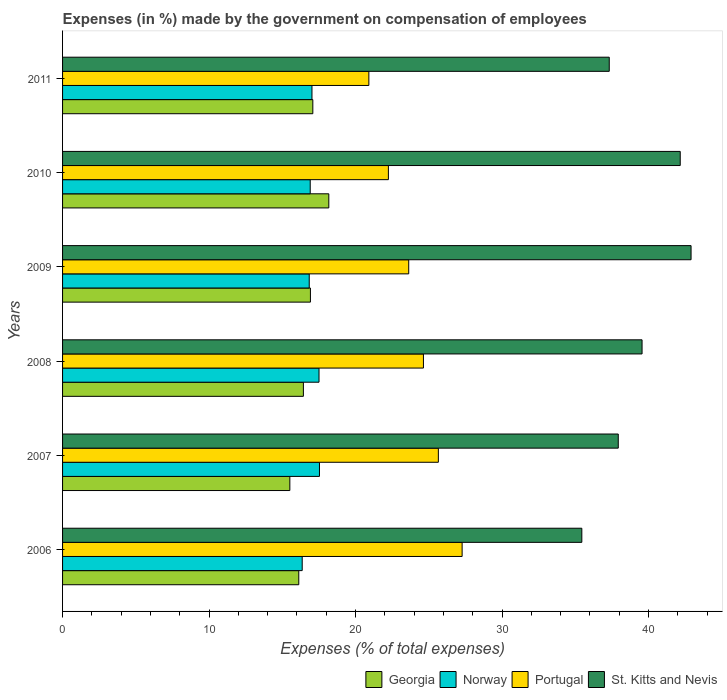How many different coloured bars are there?
Offer a very short reply. 4. Are the number of bars per tick equal to the number of legend labels?
Provide a short and direct response. Yes. Are the number of bars on each tick of the Y-axis equal?
Your answer should be compact. Yes. How many bars are there on the 5th tick from the bottom?
Ensure brevity in your answer.  4. In how many cases, is the number of bars for a given year not equal to the number of legend labels?
Provide a short and direct response. 0. What is the percentage of expenses made by the government on compensation of employees in Norway in 2008?
Your answer should be compact. 17.51. Across all years, what is the maximum percentage of expenses made by the government on compensation of employees in St. Kitts and Nevis?
Your response must be concise. 42.9. Across all years, what is the minimum percentage of expenses made by the government on compensation of employees in Norway?
Ensure brevity in your answer.  16.36. What is the total percentage of expenses made by the government on compensation of employees in Norway in the graph?
Make the answer very short. 102.17. What is the difference between the percentage of expenses made by the government on compensation of employees in Georgia in 2007 and that in 2010?
Provide a succinct answer. -2.66. What is the difference between the percentage of expenses made by the government on compensation of employees in St. Kitts and Nevis in 2006 and the percentage of expenses made by the government on compensation of employees in Georgia in 2009?
Make the answer very short. 18.53. What is the average percentage of expenses made by the government on compensation of employees in Portugal per year?
Make the answer very short. 24.06. In the year 2010, what is the difference between the percentage of expenses made by the government on compensation of employees in Norway and percentage of expenses made by the government on compensation of employees in St. Kitts and Nevis?
Provide a succinct answer. -25.26. In how many years, is the percentage of expenses made by the government on compensation of employees in St. Kitts and Nevis greater than 36 %?
Make the answer very short. 5. What is the ratio of the percentage of expenses made by the government on compensation of employees in Georgia in 2006 to that in 2010?
Provide a succinct answer. 0.89. What is the difference between the highest and the second highest percentage of expenses made by the government on compensation of employees in Norway?
Your response must be concise. 0.03. What is the difference between the highest and the lowest percentage of expenses made by the government on compensation of employees in Georgia?
Keep it short and to the point. 2.66. In how many years, is the percentage of expenses made by the government on compensation of employees in Portugal greater than the average percentage of expenses made by the government on compensation of employees in Portugal taken over all years?
Offer a terse response. 3. Is it the case that in every year, the sum of the percentage of expenses made by the government on compensation of employees in Georgia and percentage of expenses made by the government on compensation of employees in Portugal is greater than the sum of percentage of expenses made by the government on compensation of employees in Norway and percentage of expenses made by the government on compensation of employees in St. Kitts and Nevis?
Your answer should be very brief. No. What does the 1st bar from the top in 2007 represents?
Your answer should be very brief. St. Kitts and Nevis. What does the 2nd bar from the bottom in 2007 represents?
Keep it short and to the point. Norway. Is it the case that in every year, the sum of the percentage of expenses made by the government on compensation of employees in Portugal and percentage of expenses made by the government on compensation of employees in Georgia is greater than the percentage of expenses made by the government on compensation of employees in Norway?
Offer a terse response. Yes. How many bars are there?
Your response must be concise. 24. Are all the bars in the graph horizontal?
Offer a terse response. Yes. Does the graph contain any zero values?
Keep it short and to the point. No. Does the graph contain grids?
Provide a short and direct response. No. How many legend labels are there?
Keep it short and to the point. 4. How are the legend labels stacked?
Offer a very short reply. Horizontal. What is the title of the graph?
Your response must be concise. Expenses (in %) made by the government on compensation of employees. What is the label or title of the X-axis?
Provide a short and direct response. Expenses (% of total expenses). What is the Expenses (% of total expenses) in Georgia in 2006?
Keep it short and to the point. 16.12. What is the Expenses (% of total expenses) in Norway in 2006?
Your answer should be very brief. 16.36. What is the Expenses (% of total expenses) of Portugal in 2006?
Offer a terse response. 27.27. What is the Expenses (% of total expenses) in St. Kitts and Nevis in 2006?
Your answer should be compact. 35.45. What is the Expenses (% of total expenses) in Georgia in 2007?
Provide a short and direct response. 15.51. What is the Expenses (% of total expenses) in Norway in 2007?
Your answer should be compact. 17.54. What is the Expenses (% of total expenses) in Portugal in 2007?
Offer a very short reply. 25.65. What is the Expenses (% of total expenses) in St. Kitts and Nevis in 2007?
Ensure brevity in your answer.  37.93. What is the Expenses (% of total expenses) of Georgia in 2008?
Offer a very short reply. 16.44. What is the Expenses (% of total expenses) in Norway in 2008?
Your answer should be very brief. 17.51. What is the Expenses (% of total expenses) of Portugal in 2008?
Ensure brevity in your answer.  24.63. What is the Expenses (% of total expenses) in St. Kitts and Nevis in 2008?
Your answer should be compact. 39.56. What is the Expenses (% of total expenses) of Georgia in 2009?
Offer a very short reply. 16.92. What is the Expenses (% of total expenses) in Norway in 2009?
Your answer should be very brief. 16.84. What is the Expenses (% of total expenses) in Portugal in 2009?
Offer a terse response. 23.63. What is the Expenses (% of total expenses) in St. Kitts and Nevis in 2009?
Your answer should be very brief. 42.9. What is the Expenses (% of total expenses) of Georgia in 2010?
Make the answer very short. 18.17. What is the Expenses (% of total expenses) of Norway in 2010?
Provide a short and direct response. 16.91. What is the Expenses (% of total expenses) in Portugal in 2010?
Your response must be concise. 22.24. What is the Expenses (% of total expenses) in St. Kitts and Nevis in 2010?
Make the answer very short. 42.16. What is the Expenses (% of total expenses) of Georgia in 2011?
Provide a short and direct response. 17.08. What is the Expenses (% of total expenses) in Norway in 2011?
Keep it short and to the point. 17.02. What is the Expenses (% of total expenses) in Portugal in 2011?
Your answer should be very brief. 20.91. What is the Expenses (% of total expenses) in St. Kitts and Nevis in 2011?
Keep it short and to the point. 37.32. Across all years, what is the maximum Expenses (% of total expenses) of Georgia?
Provide a succinct answer. 18.17. Across all years, what is the maximum Expenses (% of total expenses) of Norway?
Provide a succinct answer. 17.54. Across all years, what is the maximum Expenses (% of total expenses) of Portugal?
Offer a very short reply. 27.27. Across all years, what is the maximum Expenses (% of total expenses) in St. Kitts and Nevis?
Ensure brevity in your answer.  42.9. Across all years, what is the minimum Expenses (% of total expenses) of Georgia?
Keep it short and to the point. 15.51. Across all years, what is the minimum Expenses (% of total expenses) of Norway?
Your response must be concise. 16.36. Across all years, what is the minimum Expenses (% of total expenses) in Portugal?
Keep it short and to the point. 20.91. Across all years, what is the minimum Expenses (% of total expenses) of St. Kitts and Nevis?
Your answer should be very brief. 35.45. What is the total Expenses (% of total expenses) in Georgia in the graph?
Give a very brief answer. 100.25. What is the total Expenses (% of total expenses) in Norway in the graph?
Keep it short and to the point. 102.17. What is the total Expenses (% of total expenses) of Portugal in the graph?
Offer a terse response. 144.34. What is the total Expenses (% of total expenses) in St. Kitts and Nevis in the graph?
Your answer should be very brief. 235.31. What is the difference between the Expenses (% of total expenses) in Georgia in 2006 and that in 2007?
Provide a succinct answer. 0.61. What is the difference between the Expenses (% of total expenses) in Norway in 2006 and that in 2007?
Offer a terse response. -1.18. What is the difference between the Expenses (% of total expenses) in Portugal in 2006 and that in 2007?
Provide a succinct answer. 1.62. What is the difference between the Expenses (% of total expenses) in St. Kitts and Nevis in 2006 and that in 2007?
Ensure brevity in your answer.  -2.49. What is the difference between the Expenses (% of total expenses) of Georgia in 2006 and that in 2008?
Your answer should be compact. -0.31. What is the difference between the Expenses (% of total expenses) in Norway in 2006 and that in 2008?
Your answer should be very brief. -1.15. What is the difference between the Expenses (% of total expenses) in Portugal in 2006 and that in 2008?
Provide a succinct answer. 2.64. What is the difference between the Expenses (% of total expenses) of St. Kitts and Nevis in 2006 and that in 2008?
Provide a succinct answer. -4.11. What is the difference between the Expenses (% of total expenses) of Georgia in 2006 and that in 2009?
Provide a short and direct response. -0.79. What is the difference between the Expenses (% of total expenses) of Norway in 2006 and that in 2009?
Ensure brevity in your answer.  -0.48. What is the difference between the Expenses (% of total expenses) in Portugal in 2006 and that in 2009?
Your answer should be compact. 3.65. What is the difference between the Expenses (% of total expenses) in St. Kitts and Nevis in 2006 and that in 2009?
Provide a short and direct response. -7.46. What is the difference between the Expenses (% of total expenses) of Georgia in 2006 and that in 2010?
Keep it short and to the point. -2.05. What is the difference between the Expenses (% of total expenses) of Norway in 2006 and that in 2010?
Make the answer very short. -0.55. What is the difference between the Expenses (% of total expenses) of Portugal in 2006 and that in 2010?
Your answer should be compact. 5.03. What is the difference between the Expenses (% of total expenses) of St. Kitts and Nevis in 2006 and that in 2010?
Offer a very short reply. -6.72. What is the difference between the Expenses (% of total expenses) in Georgia in 2006 and that in 2011?
Your answer should be very brief. -0.96. What is the difference between the Expenses (% of total expenses) in Norway in 2006 and that in 2011?
Offer a terse response. -0.67. What is the difference between the Expenses (% of total expenses) in Portugal in 2006 and that in 2011?
Your response must be concise. 6.37. What is the difference between the Expenses (% of total expenses) in St. Kitts and Nevis in 2006 and that in 2011?
Provide a succinct answer. -1.87. What is the difference between the Expenses (% of total expenses) in Georgia in 2007 and that in 2008?
Ensure brevity in your answer.  -0.92. What is the difference between the Expenses (% of total expenses) in Norway in 2007 and that in 2008?
Keep it short and to the point. 0.03. What is the difference between the Expenses (% of total expenses) of Portugal in 2007 and that in 2008?
Provide a short and direct response. 1.02. What is the difference between the Expenses (% of total expenses) in St. Kitts and Nevis in 2007 and that in 2008?
Your answer should be compact. -1.62. What is the difference between the Expenses (% of total expenses) of Georgia in 2007 and that in 2009?
Offer a very short reply. -1.41. What is the difference between the Expenses (% of total expenses) in Norway in 2007 and that in 2009?
Provide a short and direct response. 0.7. What is the difference between the Expenses (% of total expenses) of Portugal in 2007 and that in 2009?
Make the answer very short. 2.02. What is the difference between the Expenses (% of total expenses) of St. Kitts and Nevis in 2007 and that in 2009?
Your answer should be very brief. -4.97. What is the difference between the Expenses (% of total expenses) of Georgia in 2007 and that in 2010?
Your answer should be very brief. -2.66. What is the difference between the Expenses (% of total expenses) of Norway in 2007 and that in 2010?
Ensure brevity in your answer.  0.63. What is the difference between the Expenses (% of total expenses) of Portugal in 2007 and that in 2010?
Your response must be concise. 3.41. What is the difference between the Expenses (% of total expenses) of St. Kitts and Nevis in 2007 and that in 2010?
Your answer should be compact. -4.23. What is the difference between the Expenses (% of total expenses) of Georgia in 2007 and that in 2011?
Your answer should be very brief. -1.57. What is the difference between the Expenses (% of total expenses) of Norway in 2007 and that in 2011?
Keep it short and to the point. 0.51. What is the difference between the Expenses (% of total expenses) in Portugal in 2007 and that in 2011?
Your response must be concise. 4.74. What is the difference between the Expenses (% of total expenses) of St. Kitts and Nevis in 2007 and that in 2011?
Your answer should be compact. 0.62. What is the difference between the Expenses (% of total expenses) of Georgia in 2008 and that in 2009?
Offer a terse response. -0.48. What is the difference between the Expenses (% of total expenses) of Norway in 2008 and that in 2009?
Keep it short and to the point. 0.67. What is the difference between the Expenses (% of total expenses) in Portugal in 2008 and that in 2009?
Provide a succinct answer. 1. What is the difference between the Expenses (% of total expenses) of St. Kitts and Nevis in 2008 and that in 2009?
Provide a short and direct response. -3.35. What is the difference between the Expenses (% of total expenses) in Georgia in 2008 and that in 2010?
Offer a very short reply. -1.74. What is the difference between the Expenses (% of total expenses) of Norway in 2008 and that in 2010?
Keep it short and to the point. 0.6. What is the difference between the Expenses (% of total expenses) of Portugal in 2008 and that in 2010?
Keep it short and to the point. 2.39. What is the difference between the Expenses (% of total expenses) of St. Kitts and Nevis in 2008 and that in 2010?
Offer a terse response. -2.61. What is the difference between the Expenses (% of total expenses) of Georgia in 2008 and that in 2011?
Make the answer very short. -0.64. What is the difference between the Expenses (% of total expenses) in Norway in 2008 and that in 2011?
Offer a very short reply. 0.48. What is the difference between the Expenses (% of total expenses) in Portugal in 2008 and that in 2011?
Your answer should be compact. 3.73. What is the difference between the Expenses (% of total expenses) of St. Kitts and Nevis in 2008 and that in 2011?
Provide a short and direct response. 2.24. What is the difference between the Expenses (% of total expenses) of Georgia in 2009 and that in 2010?
Offer a terse response. -1.26. What is the difference between the Expenses (% of total expenses) of Norway in 2009 and that in 2010?
Give a very brief answer. -0.07. What is the difference between the Expenses (% of total expenses) in Portugal in 2009 and that in 2010?
Keep it short and to the point. 1.39. What is the difference between the Expenses (% of total expenses) in St. Kitts and Nevis in 2009 and that in 2010?
Make the answer very short. 0.74. What is the difference between the Expenses (% of total expenses) in Georgia in 2009 and that in 2011?
Your answer should be very brief. -0.16. What is the difference between the Expenses (% of total expenses) of Norway in 2009 and that in 2011?
Your answer should be very brief. -0.19. What is the difference between the Expenses (% of total expenses) of Portugal in 2009 and that in 2011?
Your answer should be very brief. 2.72. What is the difference between the Expenses (% of total expenses) of St. Kitts and Nevis in 2009 and that in 2011?
Your response must be concise. 5.58. What is the difference between the Expenses (% of total expenses) of Georgia in 2010 and that in 2011?
Give a very brief answer. 1.09. What is the difference between the Expenses (% of total expenses) of Norway in 2010 and that in 2011?
Ensure brevity in your answer.  -0.12. What is the difference between the Expenses (% of total expenses) of Portugal in 2010 and that in 2011?
Offer a very short reply. 1.33. What is the difference between the Expenses (% of total expenses) in St. Kitts and Nevis in 2010 and that in 2011?
Your answer should be compact. 4.84. What is the difference between the Expenses (% of total expenses) in Georgia in 2006 and the Expenses (% of total expenses) in Norway in 2007?
Your answer should be compact. -1.41. What is the difference between the Expenses (% of total expenses) in Georgia in 2006 and the Expenses (% of total expenses) in Portugal in 2007?
Ensure brevity in your answer.  -9.53. What is the difference between the Expenses (% of total expenses) in Georgia in 2006 and the Expenses (% of total expenses) in St. Kitts and Nevis in 2007?
Provide a short and direct response. -21.81. What is the difference between the Expenses (% of total expenses) of Norway in 2006 and the Expenses (% of total expenses) of Portugal in 2007?
Ensure brevity in your answer.  -9.29. What is the difference between the Expenses (% of total expenses) in Norway in 2006 and the Expenses (% of total expenses) in St. Kitts and Nevis in 2007?
Your answer should be very brief. -21.57. What is the difference between the Expenses (% of total expenses) in Portugal in 2006 and the Expenses (% of total expenses) in St. Kitts and Nevis in 2007?
Your answer should be very brief. -10.66. What is the difference between the Expenses (% of total expenses) in Georgia in 2006 and the Expenses (% of total expenses) in Norway in 2008?
Offer a very short reply. -1.38. What is the difference between the Expenses (% of total expenses) in Georgia in 2006 and the Expenses (% of total expenses) in Portugal in 2008?
Your answer should be compact. -8.51. What is the difference between the Expenses (% of total expenses) in Georgia in 2006 and the Expenses (% of total expenses) in St. Kitts and Nevis in 2008?
Your answer should be very brief. -23.43. What is the difference between the Expenses (% of total expenses) in Norway in 2006 and the Expenses (% of total expenses) in Portugal in 2008?
Your answer should be very brief. -8.27. What is the difference between the Expenses (% of total expenses) of Norway in 2006 and the Expenses (% of total expenses) of St. Kitts and Nevis in 2008?
Your response must be concise. -23.2. What is the difference between the Expenses (% of total expenses) in Portugal in 2006 and the Expenses (% of total expenses) in St. Kitts and Nevis in 2008?
Provide a succinct answer. -12.28. What is the difference between the Expenses (% of total expenses) of Georgia in 2006 and the Expenses (% of total expenses) of Norway in 2009?
Your response must be concise. -0.71. What is the difference between the Expenses (% of total expenses) in Georgia in 2006 and the Expenses (% of total expenses) in Portugal in 2009?
Your response must be concise. -7.5. What is the difference between the Expenses (% of total expenses) in Georgia in 2006 and the Expenses (% of total expenses) in St. Kitts and Nevis in 2009?
Offer a very short reply. -26.78. What is the difference between the Expenses (% of total expenses) in Norway in 2006 and the Expenses (% of total expenses) in Portugal in 2009?
Provide a succinct answer. -7.27. What is the difference between the Expenses (% of total expenses) in Norway in 2006 and the Expenses (% of total expenses) in St. Kitts and Nevis in 2009?
Give a very brief answer. -26.54. What is the difference between the Expenses (% of total expenses) of Portugal in 2006 and the Expenses (% of total expenses) of St. Kitts and Nevis in 2009?
Make the answer very short. -15.63. What is the difference between the Expenses (% of total expenses) in Georgia in 2006 and the Expenses (% of total expenses) in Norway in 2010?
Make the answer very short. -0.78. What is the difference between the Expenses (% of total expenses) of Georgia in 2006 and the Expenses (% of total expenses) of Portugal in 2010?
Provide a succinct answer. -6.12. What is the difference between the Expenses (% of total expenses) in Georgia in 2006 and the Expenses (% of total expenses) in St. Kitts and Nevis in 2010?
Make the answer very short. -26.04. What is the difference between the Expenses (% of total expenses) in Norway in 2006 and the Expenses (% of total expenses) in Portugal in 2010?
Give a very brief answer. -5.88. What is the difference between the Expenses (% of total expenses) in Norway in 2006 and the Expenses (% of total expenses) in St. Kitts and Nevis in 2010?
Provide a succinct answer. -25.8. What is the difference between the Expenses (% of total expenses) of Portugal in 2006 and the Expenses (% of total expenses) of St. Kitts and Nevis in 2010?
Give a very brief answer. -14.89. What is the difference between the Expenses (% of total expenses) of Georgia in 2006 and the Expenses (% of total expenses) of Norway in 2011?
Your response must be concise. -0.9. What is the difference between the Expenses (% of total expenses) of Georgia in 2006 and the Expenses (% of total expenses) of Portugal in 2011?
Your answer should be compact. -4.78. What is the difference between the Expenses (% of total expenses) of Georgia in 2006 and the Expenses (% of total expenses) of St. Kitts and Nevis in 2011?
Your response must be concise. -21.19. What is the difference between the Expenses (% of total expenses) of Norway in 2006 and the Expenses (% of total expenses) of Portugal in 2011?
Your answer should be very brief. -4.55. What is the difference between the Expenses (% of total expenses) in Norway in 2006 and the Expenses (% of total expenses) in St. Kitts and Nevis in 2011?
Ensure brevity in your answer.  -20.96. What is the difference between the Expenses (% of total expenses) in Portugal in 2006 and the Expenses (% of total expenses) in St. Kitts and Nevis in 2011?
Offer a terse response. -10.04. What is the difference between the Expenses (% of total expenses) of Georgia in 2007 and the Expenses (% of total expenses) of Norway in 2008?
Your answer should be very brief. -1.99. What is the difference between the Expenses (% of total expenses) in Georgia in 2007 and the Expenses (% of total expenses) in Portugal in 2008?
Your response must be concise. -9.12. What is the difference between the Expenses (% of total expenses) in Georgia in 2007 and the Expenses (% of total expenses) in St. Kitts and Nevis in 2008?
Your answer should be very brief. -24.04. What is the difference between the Expenses (% of total expenses) in Norway in 2007 and the Expenses (% of total expenses) in Portugal in 2008?
Your answer should be compact. -7.1. What is the difference between the Expenses (% of total expenses) in Norway in 2007 and the Expenses (% of total expenses) in St. Kitts and Nevis in 2008?
Make the answer very short. -22.02. What is the difference between the Expenses (% of total expenses) in Portugal in 2007 and the Expenses (% of total expenses) in St. Kitts and Nevis in 2008?
Make the answer very short. -13.9. What is the difference between the Expenses (% of total expenses) of Georgia in 2007 and the Expenses (% of total expenses) of Norway in 2009?
Provide a short and direct response. -1.32. What is the difference between the Expenses (% of total expenses) of Georgia in 2007 and the Expenses (% of total expenses) of Portugal in 2009?
Keep it short and to the point. -8.11. What is the difference between the Expenses (% of total expenses) in Georgia in 2007 and the Expenses (% of total expenses) in St. Kitts and Nevis in 2009?
Make the answer very short. -27.39. What is the difference between the Expenses (% of total expenses) in Norway in 2007 and the Expenses (% of total expenses) in Portugal in 2009?
Give a very brief answer. -6.09. What is the difference between the Expenses (% of total expenses) in Norway in 2007 and the Expenses (% of total expenses) in St. Kitts and Nevis in 2009?
Your answer should be compact. -25.37. What is the difference between the Expenses (% of total expenses) in Portugal in 2007 and the Expenses (% of total expenses) in St. Kitts and Nevis in 2009?
Your response must be concise. -17.25. What is the difference between the Expenses (% of total expenses) in Georgia in 2007 and the Expenses (% of total expenses) in Norway in 2010?
Your response must be concise. -1.39. What is the difference between the Expenses (% of total expenses) in Georgia in 2007 and the Expenses (% of total expenses) in Portugal in 2010?
Give a very brief answer. -6.73. What is the difference between the Expenses (% of total expenses) in Georgia in 2007 and the Expenses (% of total expenses) in St. Kitts and Nevis in 2010?
Your answer should be compact. -26.65. What is the difference between the Expenses (% of total expenses) in Norway in 2007 and the Expenses (% of total expenses) in Portugal in 2010?
Your response must be concise. -4.71. What is the difference between the Expenses (% of total expenses) of Norway in 2007 and the Expenses (% of total expenses) of St. Kitts and Nevis in 2010?
Offer a very short reply. -24.63. What is the difference between the Expenses (% of total expenses) in Portugal in 2007 and the Expenses (% of total expenses) in St. Kitts and Nevis in 2010?
Your response must be concise. -16.51. What is the difference between the Expenses (% of total expenses) in Georgia in 2007 and the Expenses (% of total expenses) in Norway in 2011?
Offer a terse response. -1.51. What is the difference between the Expenses (% of total expenses) in Georgia in 2007 and the Expenses (% of total expenses) in Portugal in 2011?
Your response must be concise. -5.39. What is the difference between the Expenses (% of total expenses) of Georgia in 2007 and the Expenses (% of total expenses) of St. Kitts and Nevis in 2011?
Offer a terse response. -21.8. What is the difference between the Expenses (% of total expenses) of Norway in 2007 and the Expenses (% of total expenses) of Portugal in 2011?
Offer a very short reply. -3.37. What is the difference between the Expenses (% of total expenses) of Norway in 2007 and the Expenses (% of total expenses) of St. Kitts and Nevis in 2011?
Offer a terse response. -19.78. What is the difference between the Expenses (% of total expenses) of Portugal in 2007 and the Expenses (% of total expenses) of St. Kitts and Nevis in 2011?
Provide a short and direct response. -11.67. What is the difference between the Expenses (% of total expenses) in Georgia in 2008 and the Expenses (% of total expenses) in Norway in 2009?
Keep it short and to the point. -0.4. What is the difference between the Expenses (% of total expenses) of Georgia in 2008 and the Expenses (% of total expenses) of Portugal in 2009?
Give a very brief answer. -7.19. What is the difference between the Expenses (% of total expenses) in Georgia in 2008 and the Expenses (% of total expenses) in St. Kitts and Nevis in 2009?
Make the answer very short. -26.46. What is the difference between the Expenses (% of total expenses) in Norway in 2008 and the Expenses (% of total expenses) in Portugal in 2009?
Make the answer very short. -6.12. What is the difference between the Expenses (% of total expenses) in Norway in 2008 and the Expenses (% of total expenses) in St. Kitts and Nevis in 2009?
Offer a very short reply. -25.4. What is the difference between the Expenses (% of total expenses) in Portugal in 2008 and the Expenses (% of total expenses) in St. Kitts and Nevis in 2009?
Provide a short and direct response. -18.27. What is the difference between the Expenses (% of total expenses) in Georgia in 2008 and the Expenses (% of total expenses) in Norway in 2010?
Make the answer very short. -0.47. What is the difference between the Expenses (% of total expenses) in Georgia in 2008 and the Expenses (% of total expenses) in Portugal in 2010?
Your answer should be compact. -5.8. What is the difference between the Expenses (% of total expenses) of Georgia in 2008 and the Expenses (% of total expenses) of St. Kitts and Nevis in 2010?
Give a very brief answer. -25.72. What is the difference between the Expenses (% of total expenses) of Norway in 2008 and the Expenses (% of total expenses) of Portugal in 2010?
Offer a terse response. -4.74. What is the difference between the Expenses (% of total expenses) of Norway in 2008 and the Expenses (% of total expenses) of St. Kitts and Nevis in 2010?
Your answer should be compact. -24.66. What is the difference between the Expenses (% of total expenses) in Portugal in 2008 and the Expenses (% of total expenses) in St. Kitts and Nevis in 2010?
Make the answer very short. -17.53. What is the difference between the Expenses (% of total expenses) of Georgia in 2008 and the Expenses (% of total expenses) of Norway in 2011?
Provide a short and direct response. -0.59. What is the difference between the Expenses (% of total expenses) in Georgia in 2008 and the Expenses (% of total expenses) in Portugal in 2011?
Offer a terse response. -4.47. What is the difference between the Expenses (% of total expenses) in Georgia in 2008 and the Expenses (% of total expenses) in St. Kitts and Nevis in 2011?
Offer a terse response. -20.88. What is the difference between the Expenses (% of total expenses) in Norway in 2008 and the Expenses (% of total expenses) in Portugal in 2011?
Your answer should be compact. -3.4. What is the difference between the Expenses (% of total expenses) in Norway in 2008 and the Expenses (% of total expenses) in St. Kitts and Nevis in 2011?
Provide a short and direct response. -19.81. What is the difference between the Expenses (% of total expenses) in Portugal in 2008 and the Expenses (% of total expenses) in St. Kitts and Nevis in 2011?
Offer a terse response. -12.68. What is the difference between the Expenses (% of total expenses) of Georgia in 2009 and the Expenses (% of total expenses) of Norway in 2010?
Offer a terse response. 0.01. What is the difference between the Expenses (% of total expenses) in Georgia in 2009 and the Expenses (% of total expenses) in Portugal in 2010?
Offer a very short reply. -5.32. What is the difference between the Expenses (% of total expenses) of Georgia in 2009 and the Expenses (% of total expenses) of St. Kitts and Nevis in 2010?
Keep it short and to the point. -25.24. What is the difference between the Expenses (% of total expenses) in Norway in 2009 and the Expenses (% of total expenses) in Portugal in 2010?
Ensure brevity in your answer.  -5.4. What is the difference between the Expenses (% of total expenses) of Norway in 2009 and the Expenses (% of total expenses) of St. Kitts and Nevis in 2010?
Your answer should be very brief. -25.32. What is the difference between the Expenses (% of total expenses) in Portugal in 2009 and the Expenses (% of total expenses) in St. Kitts and Nevis in 2010?
Make the answer very short. -18.53. What is the difference between the Expenses (% of total expenses) in Georgia in 2009 and the Expenses (% of total expenses) in Norway in 2011?
Provide a succinct answer. -0.11. What is the difference between the Expenses (% of total expenses) of Georgia in 2009 and the Expenses (% of total expenses) of Portugal in 2011?
Offer a very short reply. -3.99. What is the difference between the Expenses (% of total expenses) of Georgia in 2009 and the Expenses (% of total expenses) of St. Kitts and Nevis in 2011?
Your answer should be very brief. -20.4. What is the difference between the Expenses (% of total expenses) in Norway in 2009 and the Expenses (% of total expenses) in Portugal in 2011?
Your answer should be compact. -4.07. What is the difference between the Expenses (% of total expenses) in Norway in 2009 and the Expenses (% of total expenses) in St. Kitts and Nevis in 2011?
Provide a short and direct response. -20.48. What is the difference between the Expenses (% of total expenses) in Portugal in 2009 and the Expenses (% of total expenses) in St. Kitts and Nevis in 2011?
Offer a very short reply. -13.69. What is the difference between the Expenses (% of total expenses) of Georgia in 2010 and the Expenses (% of total expenses) of Norway in 2011?
Give a very brief answer. 1.15. What is the difference between the Expenses (% of total expenses) of Georgia in 2010 and the Expenses (% of total expenses) of Portugal in 2011?
Ensure brevity in your answer.  -2.73. What is the difference between the Expenses (% of total expenses) in Georgia in 2010 and the Expenses (% of total expenses) in St. Kitts and Nevis in 2011?
Your answer should be compact. -19.14. What is the difference between the Expenses (% of total expenses) in Norway in 2010 and the Expenses (% of total expenses) in Portugal in 2011?
Offer a very short reply. -4. What is the difference between the Expenses (% of total expenses) of Norway in 2010 and the Expenses (% of total expenses) of St. Kitts and Nevis in 2011?
Your answer should be compact. -20.41. What is the difference between the Expenses (% of total expenses) of Portugal in 2010 and the Expenses (% of total expenses) of St. Kitts and Nevis in 2011?
Ensure brevity in your answer.  -15.08. What is the average Expenses (% of total expenses) of Georgia per year?
Offer a very short reply. 16.71. What is the average Expenses (% of total expenses) of Norway per year?
Give a very brief answer. 17.03. What is the average Expenses (% of total expenses) of Portugal per year?
Your answer should be compact. 24.06. What is the average Expenses (% of total expenses) of St. Kitts and Nevis per year?
Your response must be concise. 39.22. In the year 2006, what is the difference between the Expenses (% of total expenses) of Georgia and Expenses (% of total expenses) of Norway?
Keep it short and to the point. -0.23. In the year 2006, what is the difference between the Expenses (% of total expenses) in Georgia and Expenses (% of total expenses) in Portugal?
Offer a very short reply. -11.15. In the year 2006, what is the difference between the Expenses (% of total expenses) in Georgia and Expenses (% of total expenses) in St. Kitts and Nevis?
Offer a terse response. -19.32. In the year 2006, what is the difference between the Expenses (% of total expenses) of Norway and Expenses (% of total expenses) of Portugal?
Provide a succinct answer. -10.92. In the year 2006, what is the difference between the Expenses (% of total expenses) of Norway and Expenses (% of total expenses) of St. Kitts and Nevis?
Provide a short and direct response. -19.09. In the year 2006, what is the difference between the Expenses (% of total expenses) in Portugal and Expenses (% of total expenses) in St. Kitts and Nevis?
Offer a terse response. -8.17. In the year 2007, what is the difference between the Expenses (% of total expenses) of Georgia and Expenses (% of total expenses) of Norway?
Provide a succinct answer. -2.02. In the year 2007, what is the difference between the Expenses (% of total expenses) of Georgia and Expenses (% of total expenses) of Portugal?
Offer a terse response. -10.14. In the year 2007, what is the difference between the Expenses (% of total expenses) of Georgia and Expenses (% of total expenses) of St. Kitts and Nevis?
Provide a short and direct response. -22.42. In the year 2007, what is the difference between the Expenses (% of total expenses) of Norway and Expenses (% of total expenses) of Portugal?
Your answer should be compact. -8.12. In the year 2007, what is the difference between the Expenses (% of total expenses) in Norway and Expenses (% of total expenses) in St. Kitts and Nevis?
Your response must be concise. -20.4. In the year 2007, what is the difference between the Expenses (% of total expenses) in Portugal and Expenses (% of total expenses) in St. Kitts and Nevis?
Give a very brief answer. -12.28. In the year 2008, what is the difference between the Expenses (% of total expenses) in Georgia and Expenses (% of total expenses) in Norway?
Offer a very short reply. -1.07. In the year 2008, what is the difference between the Expenses (% of total expenses) of Georgia and Expenses (% of total expenses) of Portugal?
Give a very brief answer. -8.19. In the year 2008, what is the difference between the Expenses (% of total expenses) in Georgia and Expenses (% of total expenses) in St. Kitts and Nevis?
Ensure brevity in your answer.  -23.12. In the year 2008, what is the difference between the Expenses (% of total expenses) of Norway and Expenses (% of total expenses) of Portugal?
Give a very brief answer. -7.13. In the year 2008, what is the difference between the Expenses (% of total expenses) in Norway and Expenses (% of total expenses) in St. Kitts and Nevis?
Keep it short and to the point. -22.05. In the year 2008, what is the difference between the Expenses (% of total expenses) in Portugal and Expenses (% of total expenses) in St. Kitts and Nevis?
Offer a terse response. -14.92. In the year 2009, what is the difference between the Expenses (% of total expenses) of Georgia and Expenses (% of total expenses) of Norway?
Make the answer very short. 0.08. In the year 2009, what is the difference between the Expenses (% of total expenses) in Georgia and Expenses (% of total expenses) in Portugal?
Make the answer very short. -6.71. In the year 2009, what is the difference between the Expenses (% of total expenses) in Georgia and Expenses (% of total expenses) in St. Kitts and Nevis?
Ensure brevity in your answer.  -25.98. In the year 2009, what is the difference between the Expenses (% of total expenses) in Norway and Expenses (% of total expenses) in Portugal?
Your answer should be very brief. -6.79. In the year 2009, what is the difference between the Expenses (% of total expenses) of Norway and Expenses (% of total expenses) of St. Kitts and Nevis?
Ensure brevity in your answer.  -26.06. In the year 2009, what is the difference between the Expenses (% of total expenses) in Portugal and Expenses (% of total expenses) in St. Kitts and Nevis?
Your answer should be very brief. -19.27. In the year 2010, what is the difference between the Expenses (% of total expenses) of Georgia and Expenses (% of total expenses) of Norway?
Offer a very short reply. 1.27. In the year 2010, what is the difference between the Expenses (% of total expenses) in Georgia and Expenses (% of total expenses) in Portugal?
Provide a short and direct response. -4.07. In the year 2010, what is the difference between the Expenses (% of total expenses) of Georgia and Expenses (% of total expenses) of St. Kitts and Nevis?
Provide a short and direct response. -23.99. In the year 2010, what is the difference between the Expenses (% of total expenses) in Norway and Expenses (% of total expenses) in Portugal?
Your response must be concise. -5.34. In the year 2010, what is the difference between the Expenses (% of total expenses) in Norway and Expenses (% of total expenses) in St. Kitts and Nevis?
Ensure brevity in your answer.  -25.26. In the year 2010, what is the difference between the Expenses (% of total expenses) of Portugal and Expenses (% of total expenses) of St. Kitts and Nevis?
Provide a short and direct response. -19.92. In the year 2011, what is the difference between the Expenses (% of total expenses) of Georgia and Expenses (% of total expenses) of Norway?
Ensure brevity in your answer.  0.06. In the year 2011, what is the difference between the Expenses (% of total expenses) of Georgia and Expenses (% of total expenses) of Portugal?
Give a very brief answer. -3.82. In the year 2011, what is the difference between the Expenses (% of total expenses) of Georgia and Expenses (% of total expenses) of St. Kitts and Nevis?
Keep it short and to the point. -20.23. In the year 2011, what is the difference between the Expenses (% of total expenses) of Norway and Expenses (% of total expenses) of Portugal?
Offer a terse response. -3.88. In the year 2011, what is the difference between the Expenses (% of total expenses) in Norway and Expenses (% of total expenses) in St. Kitts and Nevis?
Make the answer very short. -20.29. In the year 2011, what is the difference between the Expenses (% of total expenses) of Portugal and Expenses (% of total expenses) of St. Kitts and Nevis?
Your answer should be very brief. -16.41. What is the ratio of the Expenses (% of total expenses) in Georgia in 2006 to that in 2007?
Give a very brief answer. 1.04. What is the ratio of the Expenses (% of total expenses) in Norway in 2006 to that in 2007?
Give a very brief answer. 0.93. What is the ratio of the Expenses (% of total expenses) in Portugal in 2006 to that in 2007?
Ensure brevity in your answer.  1.06. What is the ratio of the Expenses (% of total expenses) of St. Kitts and Nevis in 2006 to that in 2007?
Offer a very short reply. 0.93. What is the ratio of the Expenses (% of total expenses) of Georgia in 2006 to that in 2008?
Your response must be concise. 0.98. What is the ratio of the Expenses (% of total expenses) in Norway in 2006 to that in 2008?
Give a very brief answer. 0.93. What is the ratio of the Expenses (% of total expenses) in Portugal in 2006 to that in 2008?
Give a very brief answer. 1.11. What is the ratio of the Expenses (% of total expenses) of St. Kitts and Nevis in 2006 to that in 2008?
Provide a succinct answer. 0.9. What is the ratio of the Expenses (% of total expenses) of Georgia in 2006 to that in 2009?
Offer a terse response. 0.95. What is the ratio of the Expenses (% of total expenses) in Norway in 2006 to that in 2009?
Keep it short and to the point. 0.97. What is the ratio of the Expenses (% of total expenses) in Portugal in 2006 to that in 2009?
Provide a short and direct response. 1.15. What is the ratio of the Expenses (% of total expenses) of St. Kitts and Nevis in 2006 to that in 2009?
Offer a terse response. 0.83. What is the ratio of the Expenses (% of total expenses) of Georgia in 2006 to that in 2010?
Provide a short and direct response. 0.89. What is the ratio of the Expenses (% of total expenses) in Norway in 2006 to that in 2010?
Ensure brevity in your answer.  0.97. What is the ratio of the Expenses (% of total expenses) of Portugal in 2006 to that in 2010?
Give a very brief answer. 1.23. What is the ratio of the Expenses (% of total expenses) of St. Kitts and Nevis in 2006 to that in 2010?
Provide a succinct answer. 0.84. What is the ratio of the Expenses (% of total expenses) in Georgia in 2006 to that in 2011?
Provide a short and direct response. 0.94. What is the ratio of the Expenses (% of total expenses) in Norway in 2006 to that in 2011?
Keep it short and to the point. 0.96. What is the ratio of the Expenses (% of total expenses) in Portugal in 2006 to that in 2011?
Offer a very short reply. 1.3. What is the ratio of the Expenses (% of total expenses) in St. Kitts and Nevis in 2006 to that in 2011?
Your response must be concise. 0.95. What is the ratio of the Expenses (% of total expenses) of Georgia in 2007 to that in 2008?
Your answer should be very brief. 0.94. What is the ratio of the Expenses (% of total expenses) of Portugal in 2007 to that in 2008?
Keep it short and to the point. 1.04. What is the ratio of the Expenses (% of total expenses) of Georgia in 2007 to that in 2009?
Make the answer very short. 0.92. What is the ratio of the Expenses (% of total expenses) of Norway in 2007 to that in 2009?
Give a very brief answer. 1.04. What is the ratio of the Expenses (% of total expenses) in Portugal in 2007 to that in 2009?
Your response must be concise. 1.09. What is the ratio of the Expenses (% of total expenses) of St. Kitts and Nevis in 2007 to that in 2009?
Provide a succinct answer. 0.88. What is the ratio of the Expenses (% of total expenses) of Georgia in 2007 to that in 2010?
Make the answer very short. 0.85. What is the ratio of the Expenses (% of total expenses) of Norway in 2007 to that in 2010?
Keep it short and to the point. 1.04. What is the ratio of the Expenses (% of total expenses) in Portugal in 2007 to that in 2010?
Provide a short and direct response. 1.15. What is the ratio of the Expenses (% of total expenses) of St. Kitts and Nevis in 2007 to that in 2010?
Your answer should be compact. 0.9. What is the ratio of the Expenses (% of total expenses) of Georgia in 2007 to that in 2011?
Your response must be concise. 0.91. What is the ratio of the Expenses (% of total expenses) of Norway in 2007 to that in 2011?
Offer a very short reply. 1.03. What is the ratio of the Expenses (% of total expenses) in Portugal in 2007 to that in 2011?
Your answer should be compact. 1.23. What is the ratio of the Expenses (% of total expenses) in St. Kitts and Nevis in 2007 to that in 2011?
Offer a very short reply. 1.02. What is the ratio of the Expenses (% of total expenses) of Georgia in 2008 to that in 2009?
Offer a very short reply. 0.97. What is the ratio of the Expenses (% of total expenses) in Norway in 2008 to that in 2009?
Your response must be concise. 1.04. What is the ratio of the Expenses (% of total expenses) of Portugal in 2008 to that in 2009?
Offer a terse response. 1.04. What is the ratio of the Expenses (% of total expenses) in St. Kitts and Nevis in 2008 to that in 2009?
Make the answer very short. 0.92. What is the ratio of the Expenses (% of total expenses) in Georgia in 2008 to that in 2010?
Provide a short and direct response. 0.9. What is the ratio of the Expenses (% of total expenses) of Norway in 2008 to that in 2010?
Make the answer very short. 1.04. What is the ratio of the Expenses (% of total expenses) in Portugal in 2008 to that in 2010?
Make the answer very short. 1.11. What is the ratio of the Expenses (% of total expenses) of St. Kitts and Nevis in 2008 to that in 2010?
Keep it short and to the point. 0.94. What is the ratio of the Expenses (% of total expenses) of Georgia in 2008 to that in 2011?
Provide a succinct answer. 0.96. What is the ratio of the Expenses (% of total expenses) in Norway in 2008 to that in 2011?
Keep it short and to the point. 1.03. What is the ratio of the Expenses (% of total expenses) in Portugal in 2008 to that in 2011?
Offer a terse response. 1.18. What is the ratio of the Expenses (% of total expenses) in St. Kitts and Nevis in 2008 to that in 2011?
Your answer should be very brief. 1.06. What is the ratio of the Expenses (% of total expenses) in Georgia in 2009 to that in 2010?
Make the answer very short. 0.93. What is the ratio of the Expenses (% of total expenses) of Norway in 2009 to that in 2010?
Provide a short and direct response. 1. What is the ratio of the Expenses (% of total expenses) of Portugal in 2009 to that in 2010?
Provide a short and direct response. 1.06. What is the ratio of the Expenses (% of total expenses) of St. Kitts and Nevis in 2009 to that in 2010?
Give a very brief answer. 1.02. What is the ratio of the Expenses (% of total expenses) in Norway in 2009 to that in 2011?
Your answer should be compact. 0.99. What is the ratio of the Expenses (% of total expenses) in Portugal in 2009 to that in 2011?
Provide a succinct answer. 1.13. What is the ratio of the Expenses (% of total expenses) of St. Kitts and Nevis in 2009 to that in 2011?
Ensure brevity in your answer.  1.15. What is the ratio of the Expenses (% of total expenses) in Georgia in 2010 to that in 2011?
Provide a short and direct response. 1.06. What is the ratio of the Expenses (% of total expenses) of Portugal in 2010 to that in 2011?
Make the answer very short. 1.06. What is the ratio of the Expenses (% of total expenses) in St. Kitts and Nevis in 2010 to that in 2011?
Your response must be concise. 1.13. What is the difference between the highest and the second highest Expenses (% of total expenses) of Georgia?
Offer a terse response. 1.09. What is the difference between the highest and the second highest Expenses (% of total expenses) in Norway?
Your response must be concise. 0.03. What is the difference between the highest and the second highest Expenses (% of total expenses) in Portugal?
Your answer should be very brief. 1.62. What is the difference between the highest and the second highest Expenses (% of total expenses) in St. Kitts and Nevis?
Provide a succinct answer. 0.74. What is the difference between the highest and the lowest Expenses (% of total expenses) in Georgia?
Give a very brief answer. 2.66. What is the difference between the highest and the lowest Expenses (% of total expenses) in Norway?
Provide a short and direct response. 1.18. What is the difference between the highest and the lowest Expenses (% of total expenses) of Portugal?
Provide a succinct answer. 6.37. What is the difference between the highest and the lowest Expenses (% of total expenses) of St. Kitts and Nevis?
Make the answer very short. 7.46. 